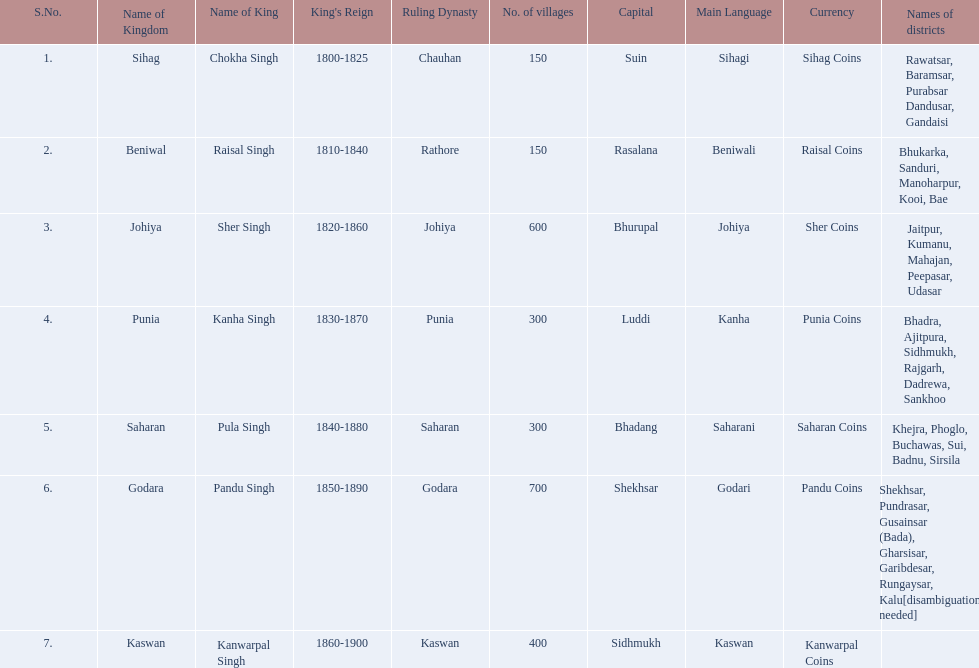What is the most amount of villages in a kingdom? 700. What is the second most amount of villages in a kingdom? 600. What kingdom has 600 villages? Johiya. 